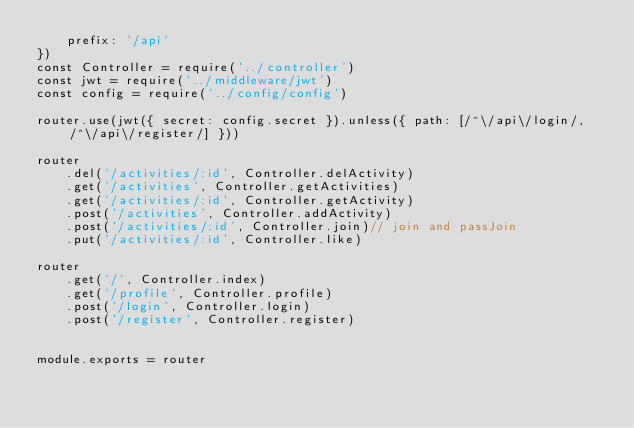Convert code to text. <code><loc_0><loc_0><loc_500><loc_500><_JavaScript_>    prefix: '/api'
})
const Controller = require('../controller')
const jwt = require('../middleware/jwt')
const config = require('../config/config')

router.use(jwt({ secret: config.secret }).unless({ path: [/^\/api\/login/, /^\/api\/register/] }))

router
    .del('/activities/:id', Controller.delActivity)
    .get('/activities', Controller.getActivities)
    .get('/activities/:id', Controller.getActivity)
    .post('/activities', Controller.addActivity)
    .post('/activities/:id', Controller.join)// join and passJoin
    .put('/activities/:id', Controller.like)

router
    .get('/', Controller.index)    
    .get('/profile', Controller.profile)    
    .post('/login', Controller.login)
    .post('/register', Controller.register)
    

module.exports = router
</code> 